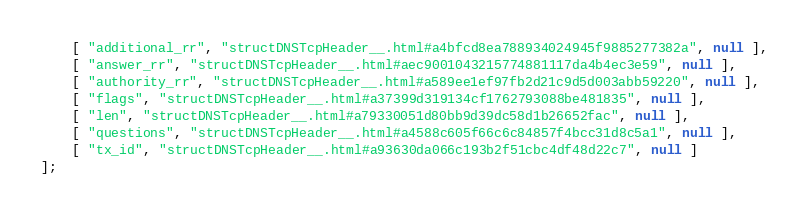Convert code to text. <code><loc_0><loc_0><loc_500><loc_500><_JavaScript_>    [ "additional_rr", "structDNSTcpHeader__.html#a4bfcd8ea788934024945f9885277382a", null ],
    [ "answer_rr", "structDNSTcpHeader__.html#aec9001043215774881117da4b4ec3e59", null ],
    [ "authority_rr", "structDNSTcpHeader__.html#a589ee1ef97fb2d21c9d5d003abb59220", null ],
    [ "flags", "structDNSTcpHeader__.html#a37399d319134cf1762793088be481835", null ],
    [ "len", "structDNSTcpHeader__.html#a79330051d80bb9d39dc58d1b26652fac", null ],
    [ "questions", "structDNSTcpHeader__.html#a4588c605f66c6c84857f4bcc31d8c5a1", null ],
    [ "tx_id", "structDNSTcpHeader__.html#a93630da066c193b2f51cbc4df48d22c7", null ]
];</code> 